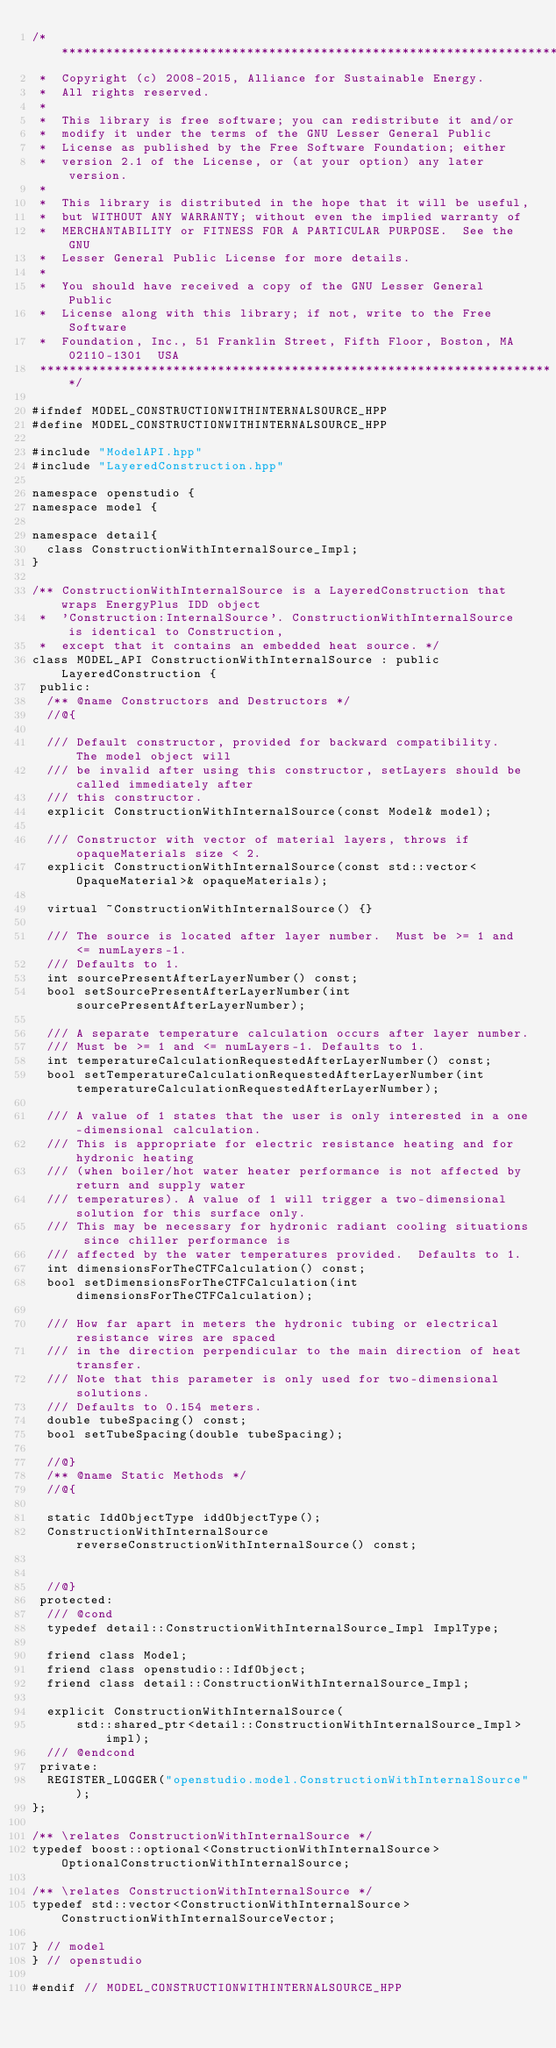Convert code to text. <code><loc_0><loc_0><loc_500><loc_500><_C++_>/**********************************************************************
 *  Copyright (c) 2008-2015, Alliance for Sustainable Energy.
 *  All rights reserved.
 *
 *  This library is free software; you can redistribute it and/or
 *  modify it under the terms of the GNU Lesser General Public
 *  License as published by the Free Software Foundation; either
 *  version 2.1 of the License, or (at your option) any later version.
 *
 *  This library is distributed in the hope that it will be useful,
 *  but WITHOUT ANY WARRANTY; without even the implied warranty of
 *  MERCHANTABILITY or FITNESS FOR A PARTICULAR PURPOSE.  See the GNU
 *  Lesser General Public License for more details.
 *
 *  You should have received a copy of the GNU Lesser General Public
 *  License along with this library; if not, write to the Free Software
 *  Foundation, Inc., 51 Franklin Street, Fifth Floor, Boston, MA  02110-1301  USA
 **********************************************************************/

#ifndef MODEL_CONSTRUCTIONWITHINTERNALSOURCE_HPP
#define MODEL_CONSTRUCTIONWITHINTERNALSOURCE_HPP

#include "ModelAPI.hpp"
#include "LayeredConstruction.hpp"

namespace openstudio {
namespace model {

namespace detail{
  class ConstructionWithInternalSource_Impl;
}

/** ConstructionWithInternalSource is a LayeredConstruction that wraps EnergyPlus IDD object 
 *  'Construction:InternalSource'. ConstructionWithInternalSource is identical to Construction, 
 *  except that it contains an embedded heat source. */
class MODEL_API ConstructionWithInternalSource : public LayeredConstruction {
 public:
  /** @name Constructors and Destructors */
  //@{

  /// Default constructor, provided for backward compatibility.  The model object will
  /// be invalid after using this constructor, setLayers should be called immediately after
  /// this constructor.
  explicit ConstructionWithInternalSource(const Model& model);

  /// Constructor with vector of material layers, throws if opaqueMaterials size < 2.
  explicit ConstructionWithInternalSource(const std::vector<OpaqueMaterial>& opaqueMaterials);

  virtual ~ConstructionWithInternalSource() {}

  /// The source is located after layer number.  Must be >= 1 and <= numLayers-1. 
  /// Defaults to 1.
  int sourcePresentAfterLayerNumber() const;
  bool setSourcePresentAfterLayerNumber(int sourcePresentAfterLayerNumber);

  /// A separate temperature calculation occurs after layer number.  
  /// Must be >= 1 and <= numLayers-1. Defaults to 1.
  int temperatureCalculationRequestedAfterLayerNumber() const;
  bool setTemperatureCalculationRequestedAfterLayerNumber(int temperatureCalculationRequestedAfterLayerNumber);

  /// A value of 1 states that the user is only interested in a one-dimensional calculation. 
  /// This is appropriate for electric resistance heating and for hydronic heating 
  /// (when boiler/hot water heater performance is not affected by return and supply water 
  /// temperatures). A value of 1 will trigger a two-dimensional solution for this surface only. 
  /// This may be necessary for hydronic radiant cooling situations since chiller performance is 
  /// affected by the water temperatures provided.  Defaults to 1.
  int dimensionsForTheCTFCalculation() const;
  bool setDimensionsForTheCTFCalculation(int dimensionsForTheCTFCalculation);

  /// How far apart in meters the hydronic tubing or electrical resistance wires are spaced 
  /// in the direction perpendicular to the main direction of heat transfer. 
  /// Note that this parameter is only used for two-dimensional solutions. 
  /// Defaults to 0.154 meters.
  double tubeSpacing() const;
  bool setTubeSpacing(double tubeSpacing);
  
  //@}
  /** @name Static Methods */
  //@{

  static IddObjectType iddObjectType();
  ConstructionWithInternalSource reverseConstructionWithInternalSource() const;


  //@}
 protected:
  /// @cond
  typedef detail::ConstructionWithInternalSource_Impl ImplType;

  friend class Model;
  friend class openstudio::IdfObject;
  friend class detail::ConstructionWithInternalSource_Impl;

  explicit ConstructionWithInternalSource(
      std::shared_ptr<detail::ConstructionWithInternalSource_Impl> impl);  
  /// @endcond
 private:
  REGISTER_LOGGER("openstudio.model.ConstructionWithInternalSource");
};

/** \relates ConstructionWithInternalSource */
typedef boost::optional<ConstructionWithInternalSource> OptionalConstructionWithInternalSource;

/** \relates ConstructionWithInternalSource */
typedef std::vector<ConstructionWithInternalSource> ConstructionWithInternalSourceVector;

} // model
} // openstudio

#endif // MODEL_CONSTRUCTIONWITHINTERNALSOURCE_HPP
</code> 